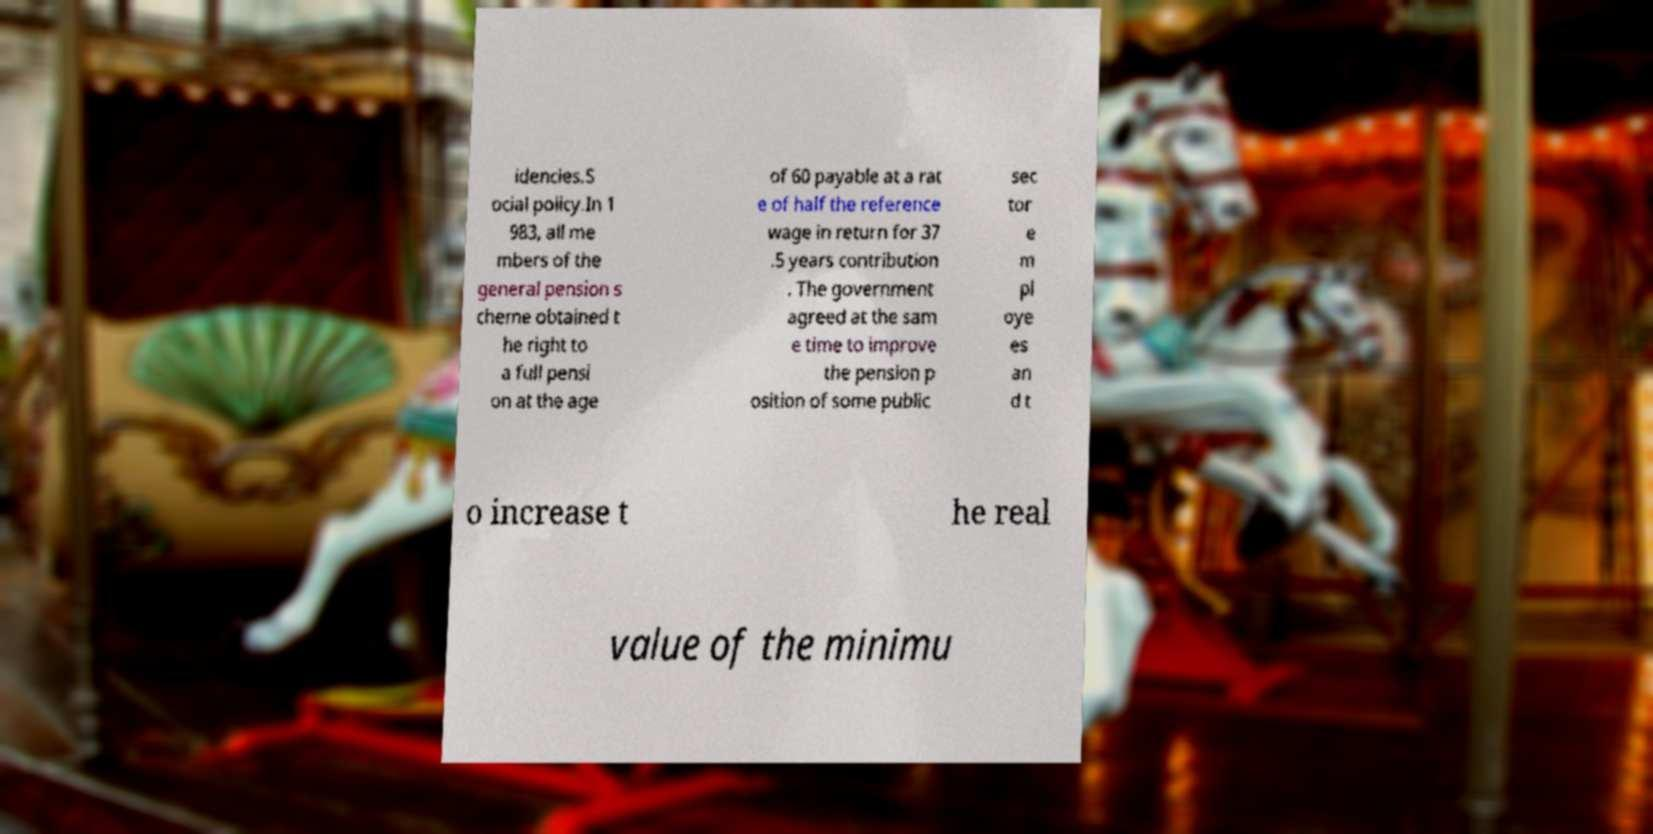Could you assist in decoding the text presented in this image and type it out clearly? idencies.S ocial policy.In 1 983, all me mbers of the general pension s cheme obtained t he right to a full pensi on at the age of 60 payable at a rat e of half the reference wage in return for 37 .5 years contribution . The government agreed at the sam e time to improve the pension p osition of some public sec tor e m pl oye es an d t o increase t he real value of the minimu 